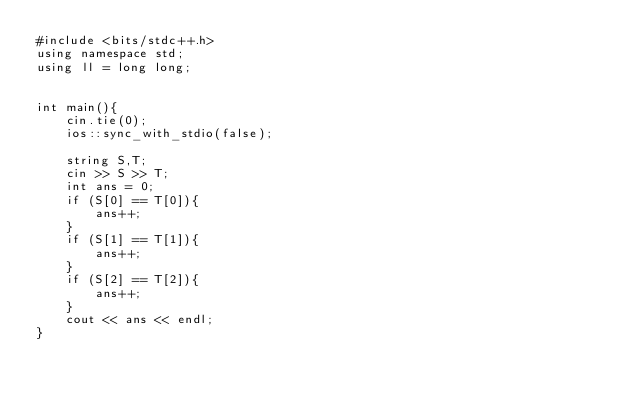Convert code to text. <code><loc_0><loc_0><loc_500><loc_500><_C++_>#include <bits/stdc++.h>
using namespace std;
using ll = long long;


int main(){
    cin.tie(0);
    ios::sync_with_stdio(false);

    string S,T;
    cin >> S >> T;
    int ans = 0;
    if (S[0] == T[0]){
        ans++;
    }
    if (S[1] == T[1]){
        ans++;
    }
    if (S[2] == T[2]){
        ans++;
    }
    cout << ans << endl;
}</code> 